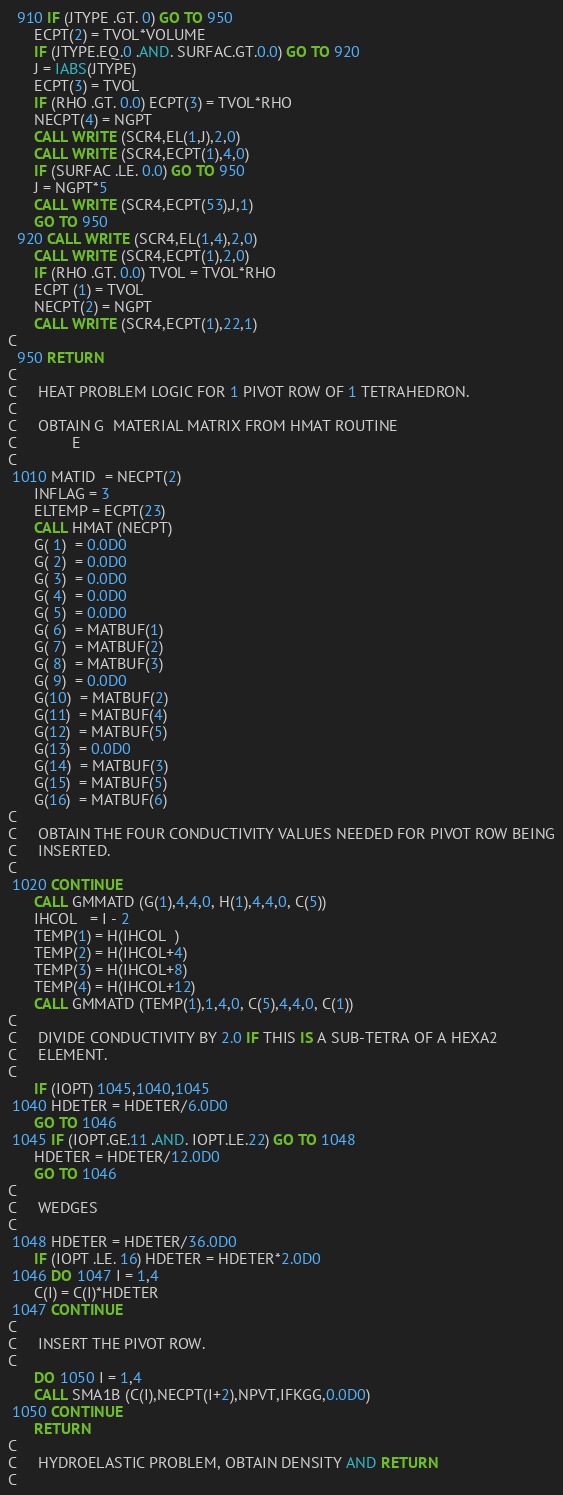Convert code to text. <code><loc_0><loc_0><loc_500><loc_500><_FORTRAN_>  910 IF (JTYPE .GT. 0) GO TO 950
      ECPT(2) = TVOL*VOLUME
      IF (JTYPE.EQ.0 .AND. SURFAC.GT.0.0) GO TO 920
      J = IABS(JTYPE)
      ECPT(3) = TVOL
      IF (RHO .GT. 0.0) ECPT(3) = TVOL*RHO
      NECPT(4) = NGPT
      CALL WRITE (SCR4,EL(1,J),2,0)
      CALL WRITE (SCR4,ECPT(1),4,0)
      IF (SURFAC .LE. 0.0) GO TO 950
      J = NGPT*5
      CALL WRITE (SCR4,ECPT(53),J,1)
      GO TO 950
  920 CALL WRITE (SCR4,EL(1,4),2,0)
      CALL WRITE (SCR4,ECPT(1),2,0)
      IF (RHO .GT. 0.0) TVOL = TVOL*RHO
      ECPT (1) = TVOL
      NECPT(2) = NGPT
      CALL WRITE (SCR4,ECPT(1),22,1)
C
  950 RETURN
C
C     HEAT PROBLEM LOGIC FOR 1 PIVOT ROW OF 1 TETRAHEDRON.
C
C     OBTAIN G  MATERIAL MATRIX FROM HMAT ROUTINE
C             E
C
 1010 MATID  = NECPT(2)
      INFLAG = 3
      ELTEMP = ECPT(23)
      CALL HMAT (NECPT)
      G( 1)  = 0.0D0
      G( 2)  = 0.0D0
      G( 3)  = 0.0D0
      G( 4)  = 0.0D0
      G( 5)  = 0.0D0
      G( 6)  = MATBUF(1)
      G( 7)  = MATBUF(2)
      G( 8)  = MATBUF(3)
      G( 9)  = 0.0D0
      G(10)  = MATBUF(2)
      G(11)  = MATBUF(4)
      G(12)  = MATBUF(5)
      G(13)  = 0.0D0
      G(14)  = MATBUF(3)
      G(15)  = MATBUF(5)
      G(16)  = MATBUF(6)
C
C     OBTAIN THE FOUR CONDUCTIVITY VALUES NEEDED FOR PIVOT ROW BEING
C     INSERTED.
C
 1020 CONTINUE
      CALL GMMATD (G(1),4,4,0, H(1),4,4,0, C(5))
      IHCOL   = I - 2
      TEMP(1) = H(IHCOL  )
      TEMP(2) = H(IHCOL+4)
      TEMP(3) = H(IHCOL+8)
      TEMP(4) = H(IHCOL+12)
      CALL GMMATD (TEMP(1),1,4,0, C(5),4,4,0, C(1))
C
C     DIVIDE CONDUCTIVITY BY 2.0 IF THIS IS A SUB-TETRA OF A HEXA2
C     ELEMENT.
C
      IF (IOPT) 1045,1040,1045
 1040 HDETER = HDETER/6.0D0
      GO TO 1046
 1045 IF (IOPT.GE.11 .AND. IOPT.LE.22) GO TO 1048
      HDETER = HDETER/12.0D0
      GO TO 1046
C
C     WEDGES
C
 1048 HDETER = HDETER/36.0D0
      IF (IOPT .LE. 16) HDETER = HDETER*2.0D0
 1046 DO 1047 I = 1,4
      C(I) = C(I)*HDETER
 1047 CONTINUE
C
C     INSERT THE PIVOT ROW.
C
      DO 1050 I = 1,4
      CALL SMA1B (C(I),NECPT(I+2),NPVT,IFKGG,0.0D0)
 1050 CONTINUE
      RETURN
C
C     HYDROELASTIC PROBLEM, OBTAIN DENSITY AND RETURN
C</code> 